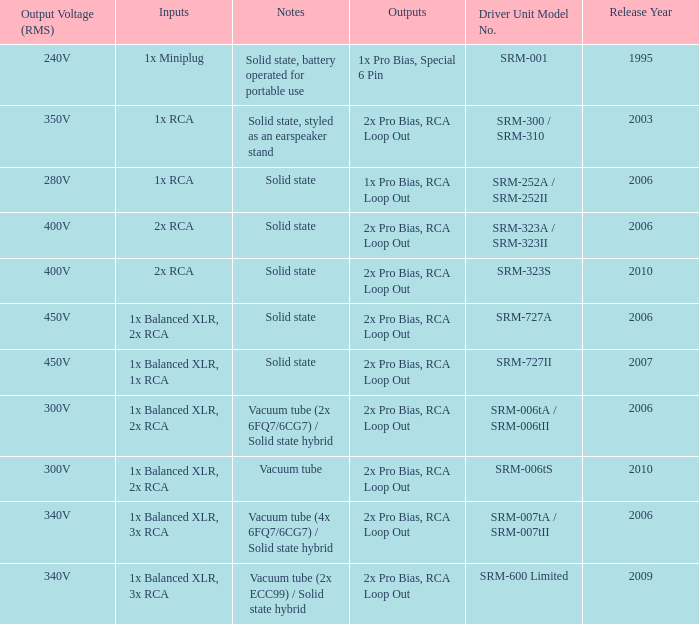How many outputs are there for solid state, battery operated for portable use listed in notes? 1.0. 